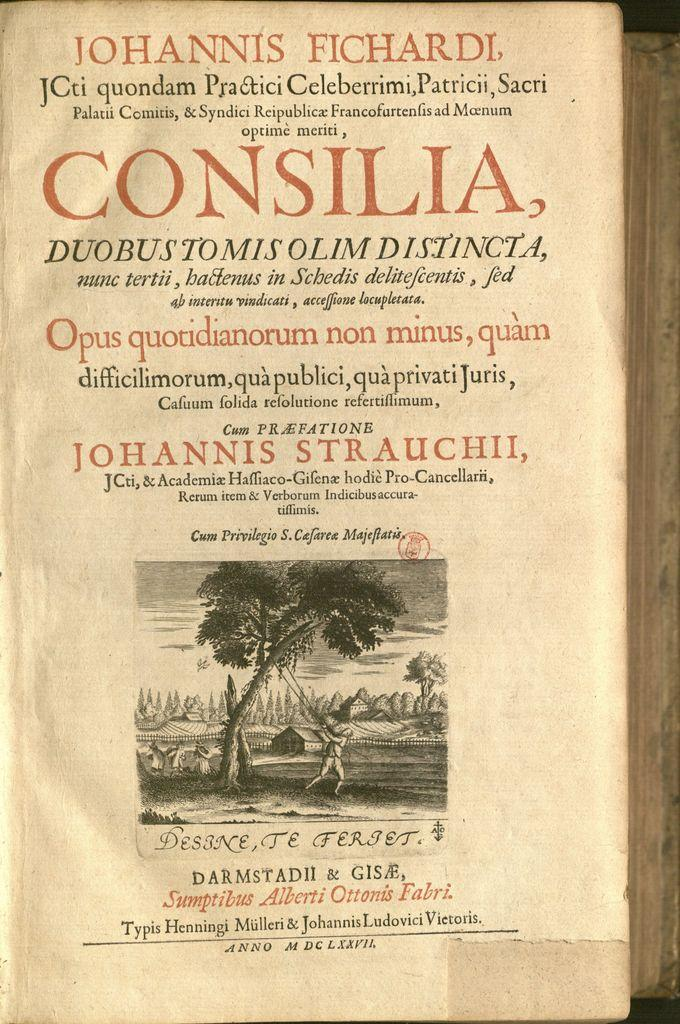<image>
Describe the image concisely. The opening page of a book called Consilia with an illustration of a man sawing a limb. 